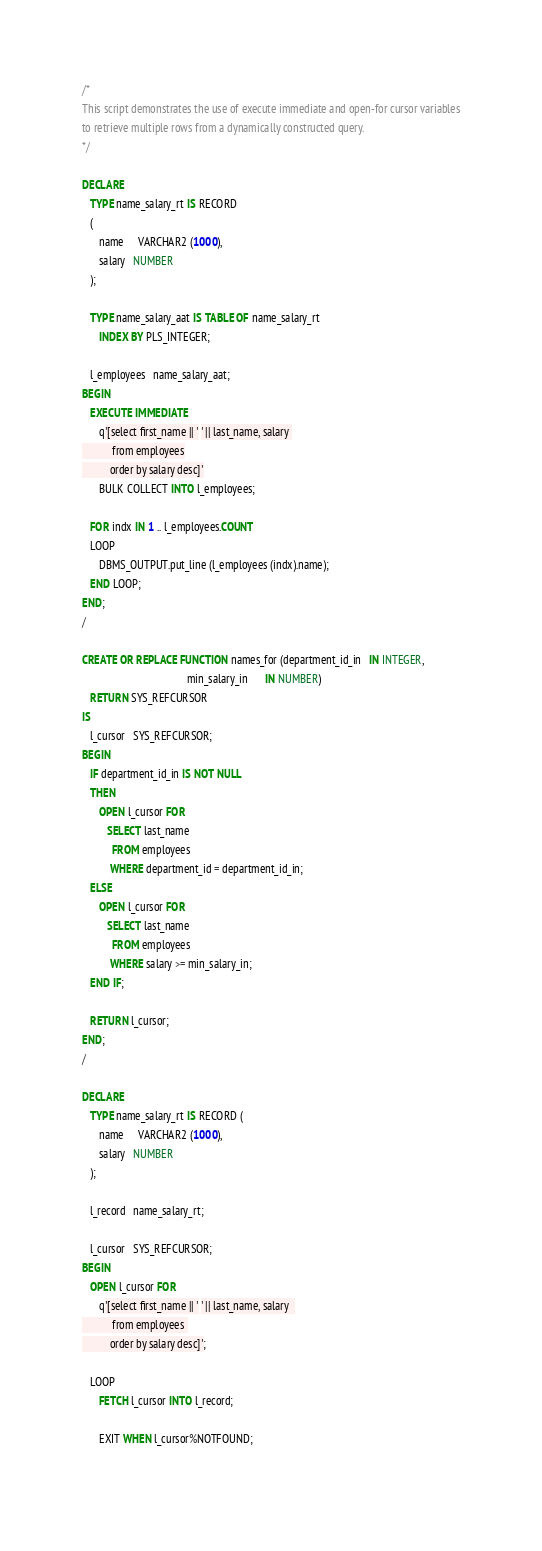Convert code to text. <code><loc_0><loc_0><loc_500><loc_500><_SQL_>/*
This script demonstrates the use of execute immediate and open-for cursor variables
to retrieve multiple rows from a dynamically constructed query.
*/

DECLARE
   TYPE name_salary_rt IS RECORD
   (
      name     VARCHAR2 (1000),
      salary   NUMBER
   );

   TYPE name_salary_aat IS TABLE OF name_salary_rt
      INDEX BY PLS_INTEGER;

   l_employees   name_salary_aat;
BEGIN
   EXECUTE IMMEDIATE 
      q'[select first_name || ' ' || last_name, salary 
           from employees
          order by salary desc]'
      BULK COLLECT INTO l_employees;

   FOR indx IN 1 .. l_employees.COUNT
   LOOP
      DBMS_OUTPUT.put_line (l_employees (indx).name);
   END LOOP;
END;
/

CREATE OR REPLACE FUNCTION names_for (department_id_in   IN INTEGER,
                                      min_salary_in      IN NUMBER)
   RETURN SYS_REFCURSOR
IS
   l_cursor   SYS_REFCURSOR;
BEGIN
   IF department_id_in IS NOT NULL
   THEN
      OPEN l_cursor FOR
         SELECT last_name
           FROM employees
          WHERE department_id = department_id_in;
   ELSE
      OPEN l_cursor FOR
         SELECT last_name
           FROM employees
          WHERE salary >= min_salary_in;
   END IF;

   RETURN l_cursor;
END;
/

DECLARE 
   TYPE name_salary_rt IS RECORD ( 
      name     VARCHAR2 (1000), 
      salary   NUMBER 
   ); 
 
   l_record   name_salary_rt; 
 
   l_cursor   SYS_REFCURSOR; 
BEGIN 
   OPEN l_cursor FOR  
      q'[select first_name || ' ' || last_name, salary  
           from employees 
          order by salary desc]'; 
 
   LOOP 
      FETCH l_cursor INTO l_record; 
 
      EXIT WHEN l_cursor%NOTFOUND; 
 </code> 